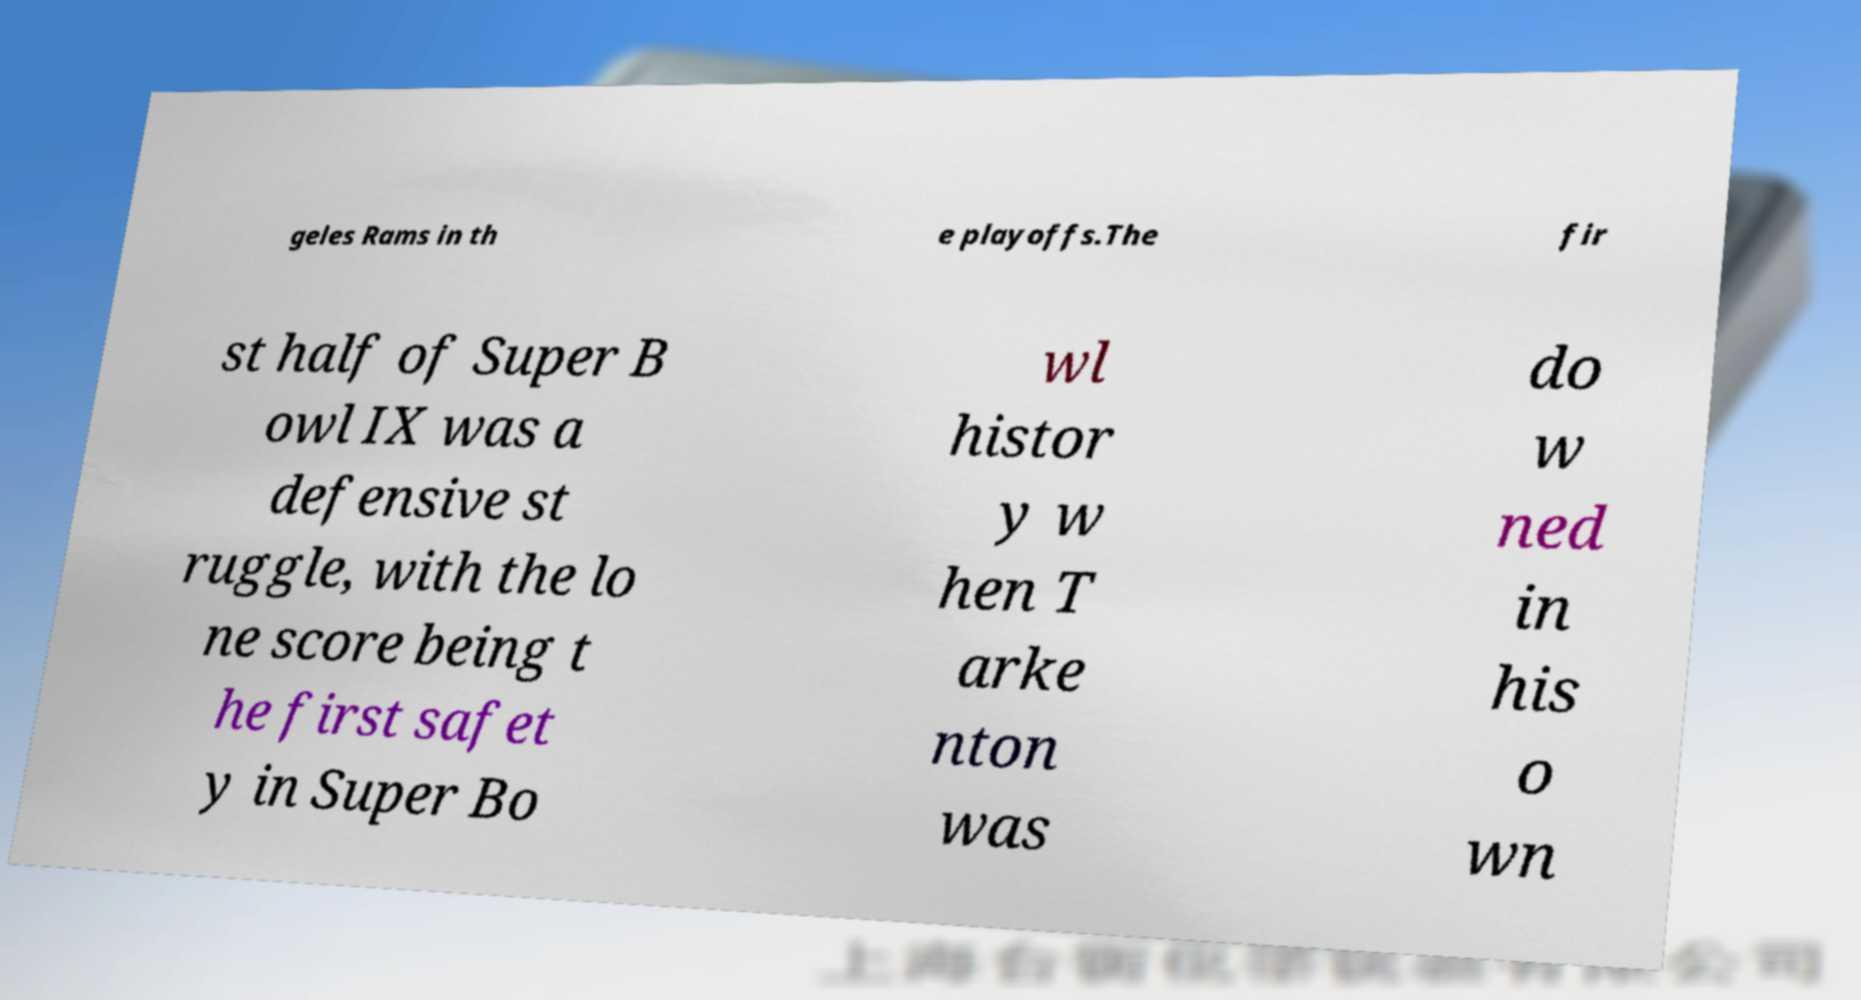Please identify and transcribe the text found in this image. geles Rams in th e playoffs.The fir st half of Super B owl IX was a defensive st ruggle, with the lo ne score being t he first safet y in Super Bo wl histor y w hen T arke nton was do w ned in his o wn 